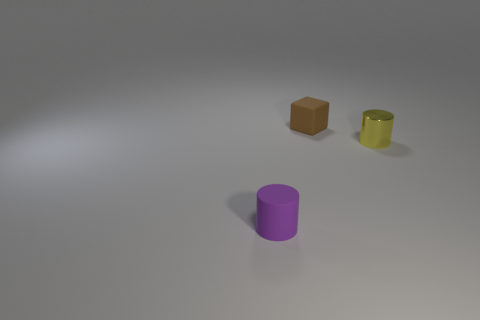Add 2 big brown rubber balls. How many objects exist? 5 Subtract all cylinders. How many objects are left? 1 Add 3 small purple matte things. How many small purple matte things are left? 4 Add 1 brown rubber objects. How many brown rubber objects exist? 2 Subtract 0 gray cylinders. How many objects are left? 3 Subtract all yellow cylinders. Subtract all purple objects. How many objects are left? 1 